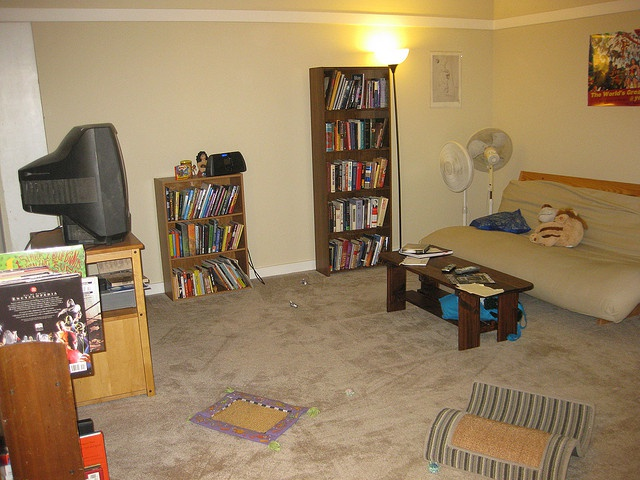Describe the objects in this image and their specific colors. I can see book in gray, maroon, and black tones, bed in gray, olive, and tan tones, couch in gray, olive, and tan tones, tv in gray and black tones, and book in gray, black, olive, and darkgray tones in this image. 